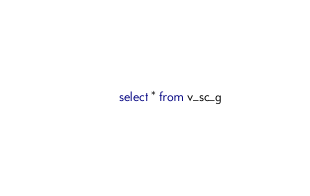<code> <loc_0><loc_0><loc_500><loc_500><_SQL_>select * from v_sc_g</code> 